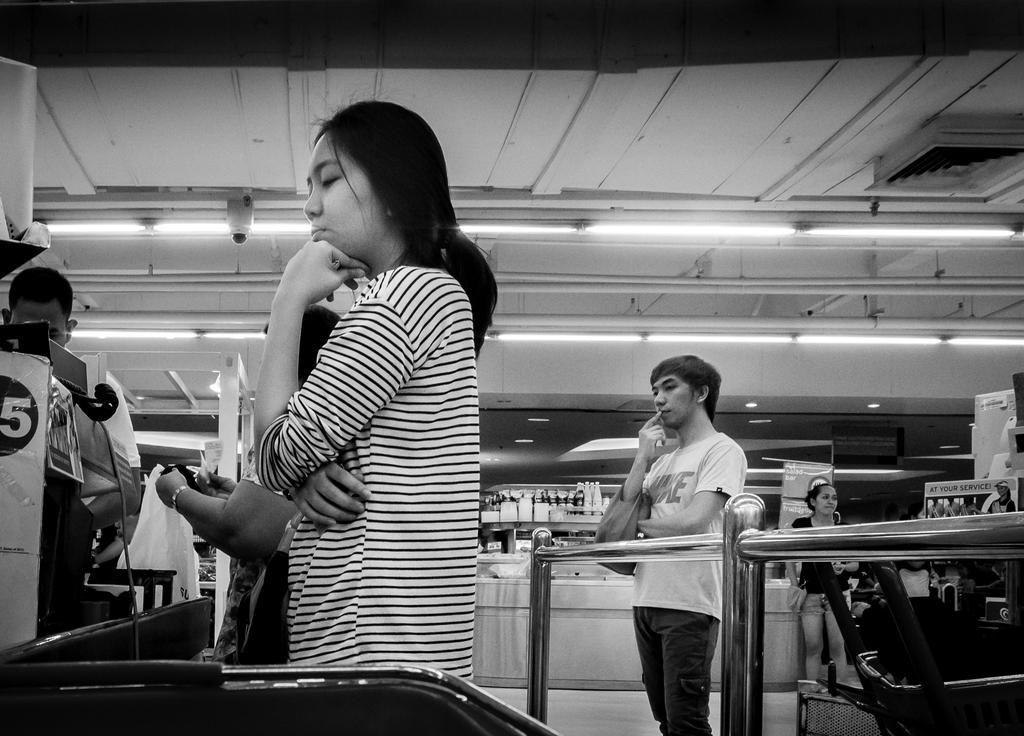What is the color scheme of the image? The image is black and white. What can be seen in the image? There are people standing in the image. What is the purpose of the railing visible in the image? The railing may provide support or serve as a barrier in the image. What is the surface that the people are standing on? The floor is present in the image. What are the objects on racks in the image used for? The objects on racks may be for storage or display purposes. What is the source of light in the image? There are lights on the ceiling in the image. Can you describe the objects visible in the image? There are objects visible in the image, but their specific nature cannot be determined from the provided facts. What type of zinc is present in the image? There is no zinc present in the image. Can you see a cat playing with a ball of yarn in the image? There is no cat or ball of yarn present in the image. 